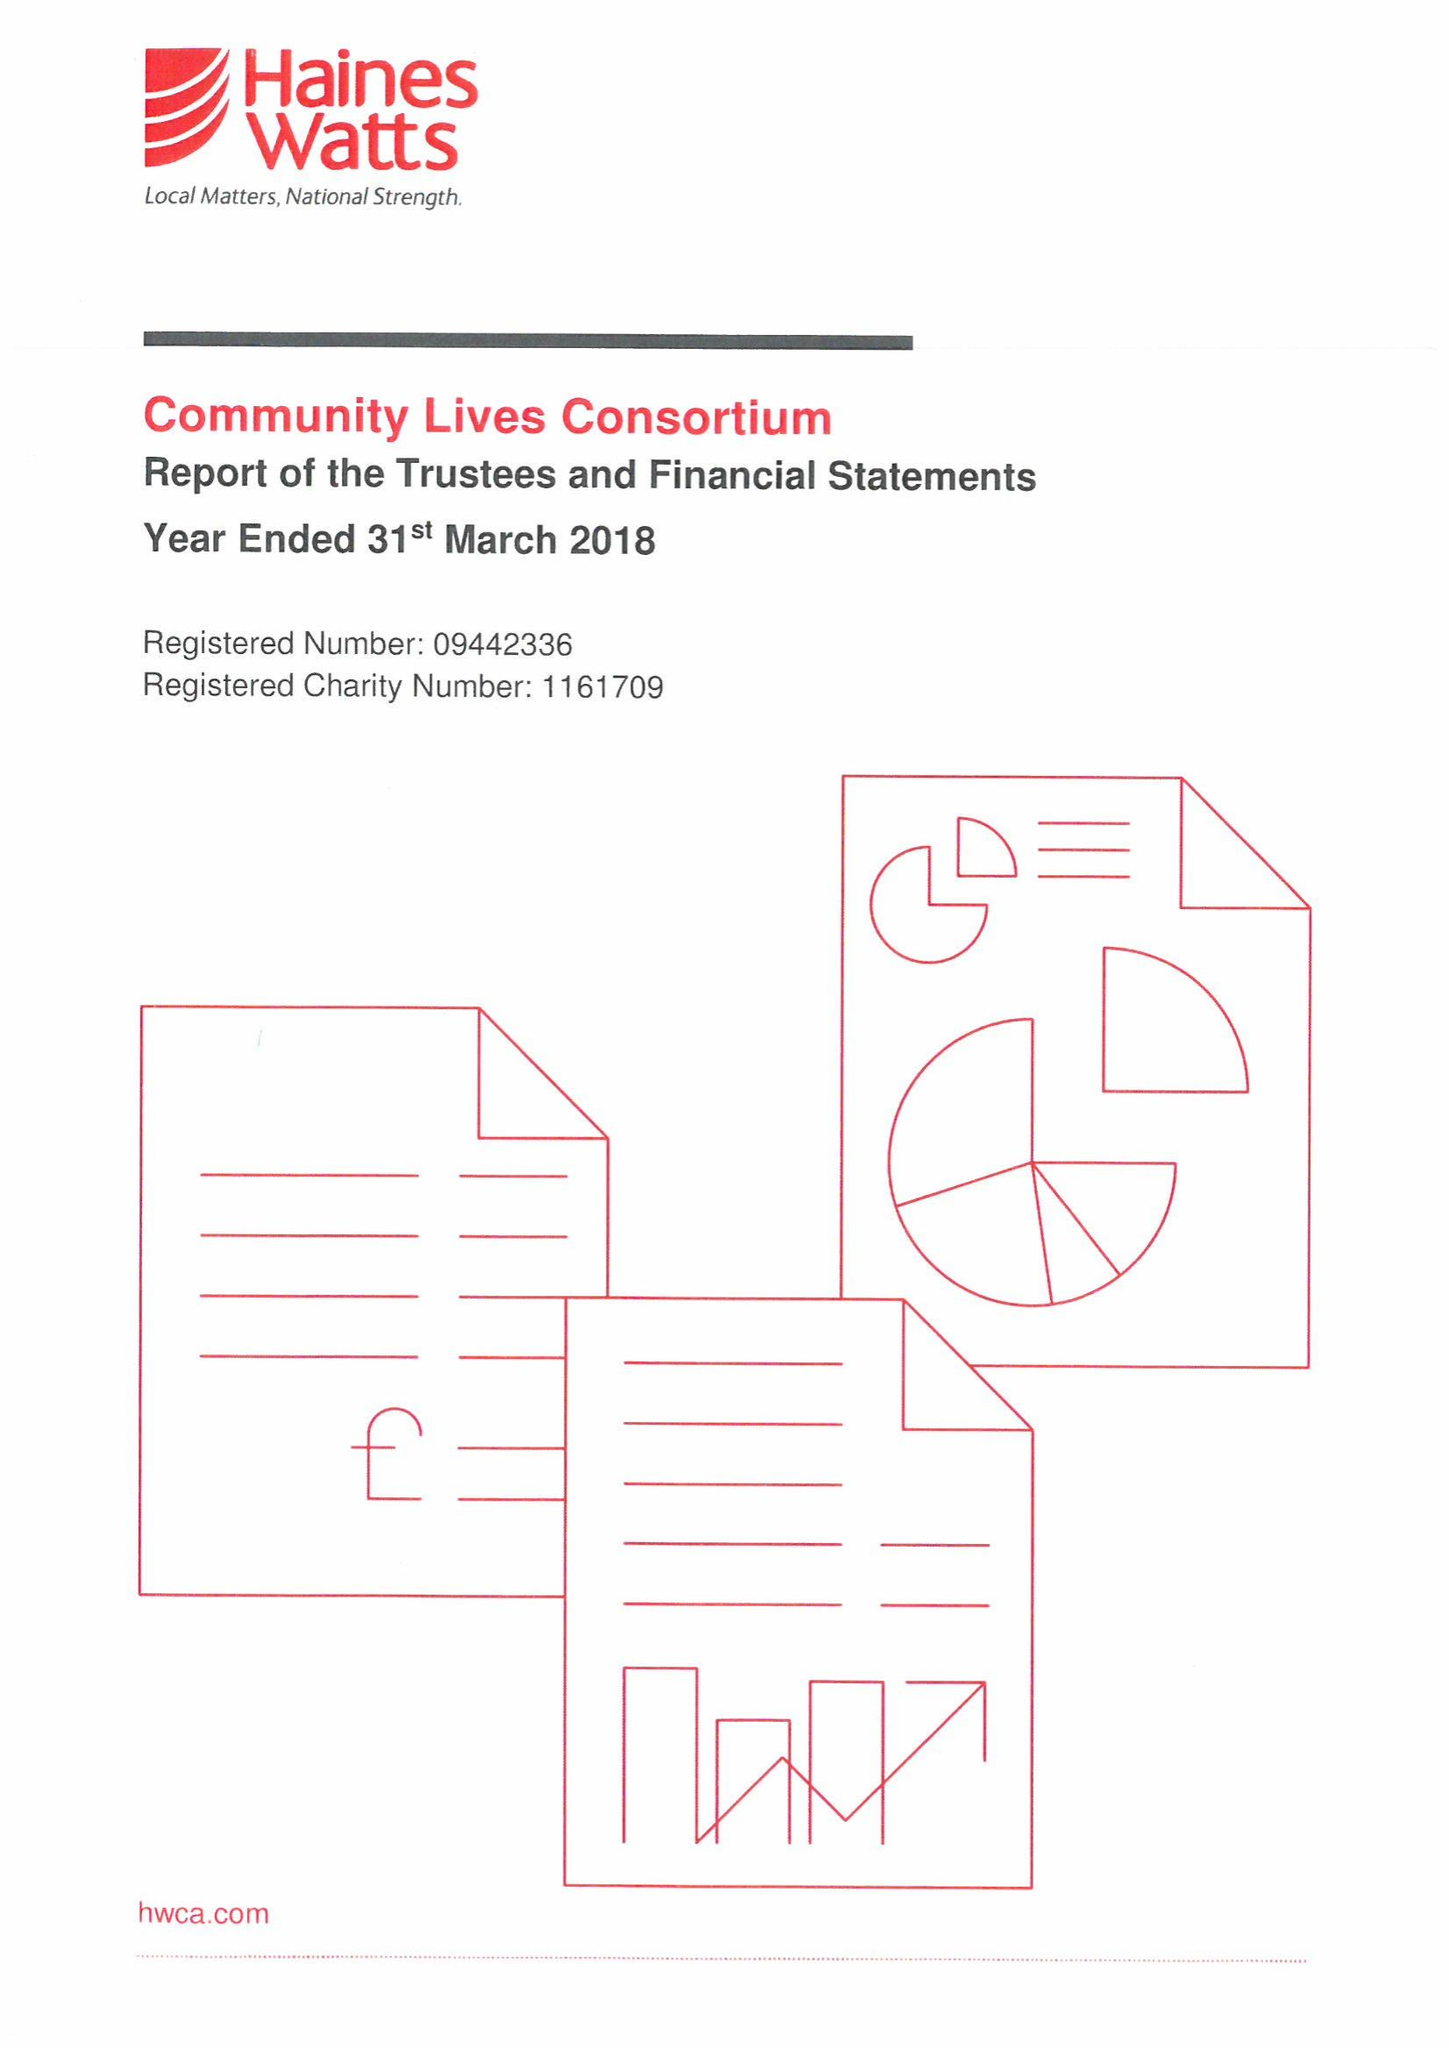What is the value for the income_annually_in_british_pounds?
Answer the question using a single word or phrase. 16091768.00 